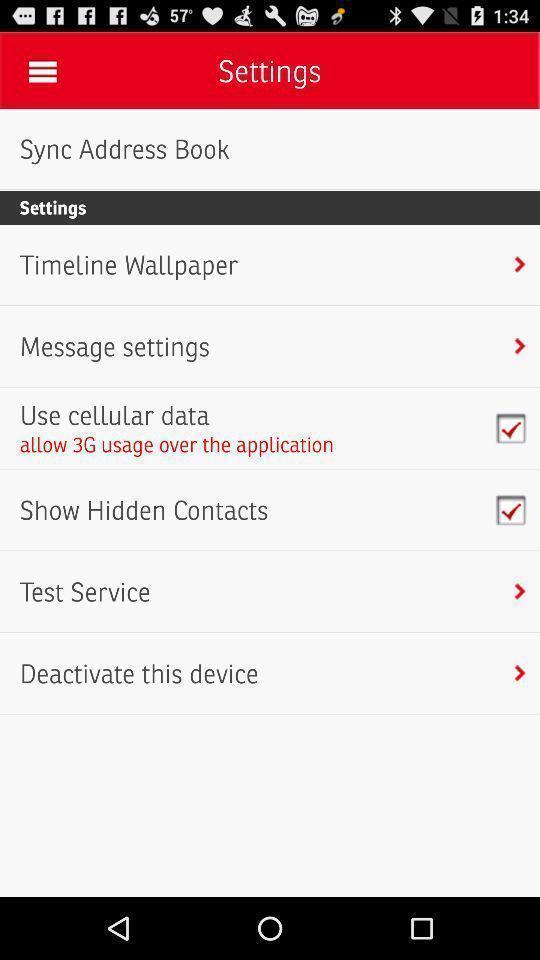Please provide a description for this image. Settings page with various options. 